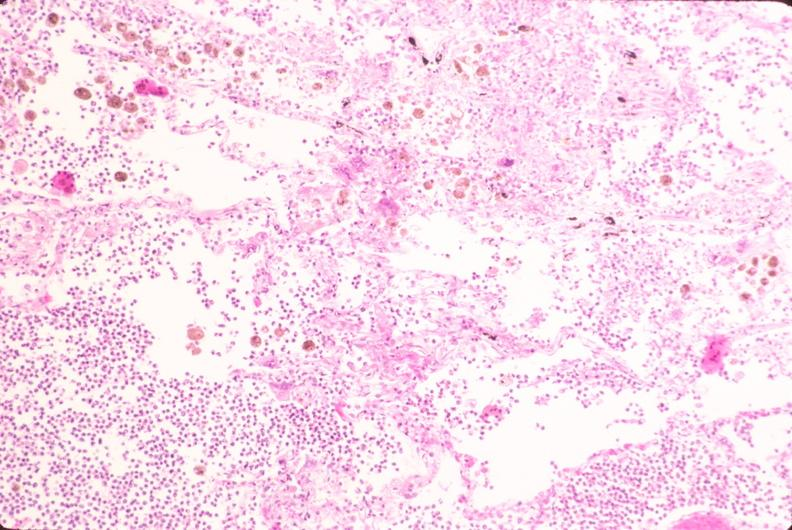s respiratory present?
Answer the question using a single word or phrase. Yes 